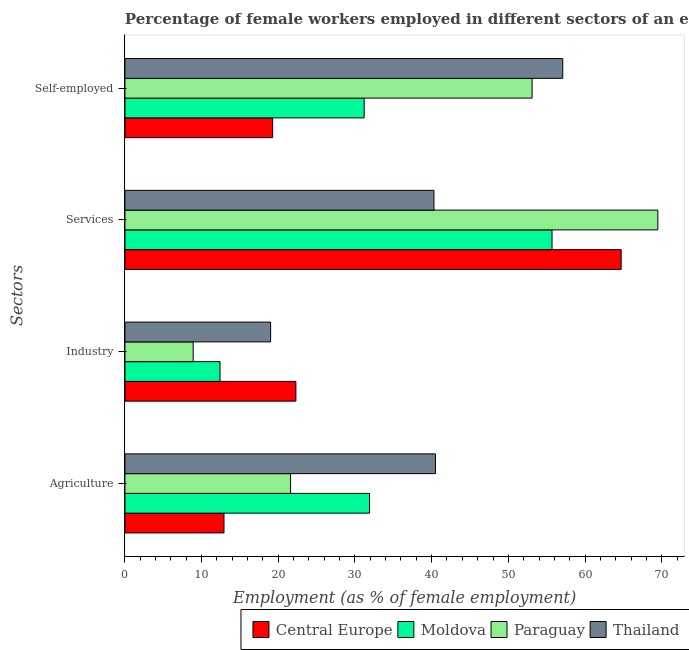Are the number of bars on each tick of the Y-axis equal?
Make the answer very short. Yes. How many bars are there on the 3rd tick from the top?
Your answer should be very brief. 4. How many bars are there on the 1st tick from the bottom?
Keep it short and to the point. 4. What is the label of the 2nd group of bars from the top?
Provide a succinct answer. Services. Across all countries, what is the maximum percentage of female workers in industry?
Ensure brevity in your answer.  22.29. Across all countries, what is the minimum percentage of female workers in services?
Give a very brief answer. 40.3. In which country was the percentage of female workers in agriculture maximum?
Keep it short and to the point. Thailand. In which country was the percentage of female workers in agriculture minimum?
Your response must be concise. Central Europe. What is the total percentage of female workers in services in the graph?
Your response must be concise. 230.21. What is the difference between the percentage of female workers in services in Thailand and that in Paraguay?
Give a very brief answer. -29.2. What is the difference between the percentage of female workers in agriculture in Moldova and the percentage of female workers in services in Thailand?
Your response must be concise. -8.4. What is the average percentage of female workers in industry per country?
Offer a very short reply. 15.65. What is the difference between the percentage of female workers in services and percentage of female workers in industry in Paraguay?
Keep it short and to the point. 60.6. What is the ratio of the percentage of female workers in services in Moldova to that in Paraguay?
Provide a succinct answer. 0.8. Is the percentage of self employed female workers in Moldova less than that in Paraguay?
Provide a short and direct response. Yes. Is the difference between the percentage of female workers in industry in Thailand and Moldova greater than the difference between the percentage of female workers in services in Thailand and Moldova?
Provide a short and direct response. Yes. What is the difference between the highest and the second highest percentage of female workers in agriculture?
Offer a very short reply. 8.6. What is the difference between the highest and the lowest percentage of female workers in industry?
Provide a short and direct response. 13.39. What does the 3rd bar from the top in Self-employed represents?
Your answer should be compact. Moldova. What does the 3rd bar from the bottom in Services represents?
Offer a terse response. Paraguay. Is it the case that in every country, the sum of the percentage of female workers in agriculture and percentage of female workers in industry is greater than the percentage of female workers in services?
Provide a short and direct response. No. Are all the bars in the graph horizontal?
Your answer should be very brief. Yes. How many countries are there in the graph?
Provide a short and direct response. 4. What is the difference between two consecutive major ticks on the X-axis?
Keep it short and to the point. 10. Does the graph contain any zero values?
Offer a very short reply. No. How are the legend labels stacked?
Your response must be concise. Horizontal. What is the title of the graph?
Offer a very short reply. Percentage of female workers employed in different sectors of an economy in 2006. What is the label or title of the X-axis?
Provide a short and direct response. Employment (as % of female employment). What is the label or title of the Y-axis?
Your response must be concise. Sectors. What is the Employment (as % of female employment) of Central Europe in Agriculture?
Give a very brief answer. 12.92. What is the Employment (as % of female employment) in Moldova in Agriculture?
Keep it short and to the point. 31.9. What is the Employment (as % of female employment) of Paraguay in Agriculture?
Give a very brief answer. 21.6. What is the Employment (as % of female employment) in Thailand in Agriculture?
Keep it short and to the point. 40.5. What is the Employment (as % of female employment) of Central Europe in Industry?
Your response must be concise. 22.29. What is the Employment (as % of female employment) of Moldova in Industry?
Make the answer very short. 12.4. What is the Employment (as % of female employment) in Paraguay in Industry?
Provide a short and direct response. 8.9. What is the Employment (as % of female employment) of Thailand in Industry?
Offer a terse response. 19. What is the Employment (as % of female employment) in Central Europe in Services?
Your answer should be very brief. 64.71. What is the Employment (as % of female employment) in Moldova in Services?
Provide a succinct answer. 55.7. What is the Employment (as % of female employment) of Paraguay in Services?
Offer a very short reply. 69.5. What is the Employment (as % of female employment) of Thailand in Services?
Keep it short and to the point. 40.3. What is the Employment (as % of female employment) of Central Europe in Self-employed?
Your answer should be compact. 19.26. What is the Employment (as % of female employment) in Moldova in Self-employed?
Provide a succinct answer. 31.2. What is the Employment (as % of female employment) of Paraguay in Self-employed?
Offer a terse response. 53.1. What is the Employment (as % of female employment) of Thailand in Self-employed?
Your answer should be very brief. 57.1. Across all Sectors, what is the maximum Employment (as % of female employment) of Central Europe?
Make the answer very short. 64.71. Across all Sectors, what is the maximum Employment (as % of female employment) of Moldova?
Your answer should be very brief. 55.7. Across all Sectors, what is the maximum Employment (as % of female employment) of Paraguay?
Offer a very short reply. 69.5. Across all Sectors, what is the maximum Employment (as % of female employment) in Thailand?
Make the answer very short. 57.1. Across all Sectors, what is the minimum Employment (as % of female employment) of Central Europe?
Make the answer very short. 12.92. Across all Sectors, what is the minimum Employment (as % of female employment) in Moldova?
Ensure brevity in your answer.  12.4. Across all Sectors, what is the minimum Employment (as % of female employment) of Paraguay?
Keep it short and to the point. 8.9. Across all Sectors, what is the minimum Employment (as % of female employment) in Thailand?
Your answer should be compact. 19. What is the total Employment (as % of female employment) in Central Europe in the graph?
Keep it short and to the point. 119.19. What is the total Employment (as % of female employment) of Moldova in the graph?
Ensure brevity in your answer.  131.2. What is the total Employment (as % of female employment) of Paraguay in the graph?
Offer a very short reply. 153.1. What is the total Employment (as % of female employment) of Thailand in the graph?
Give a very brief answer. 156.9. What is the difference between the Employment (as % of female employment) in Central Europe in Agriculture and that in Industry?
Provide a short and direct response. -9.37. What is the difference between the Employment (as % of female employment) in Moldova in Agriculture and that in Industry?
Provide a succinct answer. 19.5. What is the difference between the Employment (as % of female employment) in Paraguay in Agriculture and that in Industry?
Your answer should be compact. 12.7. What is the difference between the Employment (as % of female employment) of Central Europe in Agriculture and that in Services?
Offer a terse response. -51.8. What is the difference between the Employment (as % of female employment) of Moldova in Agriculture and that in Services?
Give a very brief answer. -23.8. What is the difference between the Employment (as % of female employment) of Paraguay in Agriculture and that in Services?
Make the answer very short. -47.9. What is the difference between the Employment (as % of female employment) of Central Europe in Agriculture and that in Self-employed?
Ensure brevity in your answer.  -6.34. What is the difference between the Employment (as % of female employment) in Paraguay in Agriculture and that in Self-employed?
Provide a short and direct response. -31.5. What is the difference between the Employment (as % of female employment) in Thailand in Agriculture and that in Self-employed?
Your answer should be very brief. -16.6. What is the difference between the Employment (as % of female employment) of Central Europe in Industry and that in Services?
Make the answer very short. -42.42. What is the difference between the Employment (as % of female employment) in Moldova in Industry and that in Services?
Make the answer very short. -43.3. What is the difference between the Employment (as % of female employment) of Paraguay in Industry and that in Services?
Provide a succinct answer. -60.6. What is the difference between the Employment (as % of female employment) of Thailand in Industry and that in Services?
Your answer should be very brief. -21.3. What is the difference between the Employment (as % of female employment) of Central Europe in Industry and that in Self-employed?
Keep it short and to the point. 3.03. What is the difference between the Employment (as % of female employment) in Moldova in Industry and that in Self-employed?
Your answer should be compact. -18.8. What is the difference between the Employment (as % of female employment) in Paraguay in Industry and that in Self-employed?
Give a very brief answer. -44.2. What is the difference between the Employment (as % of female employment) in Thailand in Industry and that in Self-employed?
Keep it short and to the point. -38.1. What is the difference between the Employment (as % of female employment) in Central Europe in Services and that in Self-employed?
Keep it short and to the point. 45.45. What is the difference between the Employment (as % of female employment) in Paraguay in Services and that in Self-employed?
Make the answer very short. 16.4. What is the difference between the Employment (as % of female employment) in Thailand in Services and that in Self-employed?
Your response must be concise. -16.8. What is the difference between the Employment (as % of female employment) in Central Europe in Agriculture and the Employment (as % of female employment) in Moldova in Industry?
Offer a very short reply. 0.52. What is the difference between the Employment (as % of female employment) of Central Europe in Agriculture and the Employment (as % of female employment) of Paraguay in Industry?
Your answer should be very brief. 4.02. What is the difference between the Employment (as % of female employment) of Central Europe in Agriculture and the Employment (as % of female employment) of Thailand in Industry?
Offer a very short reply. -6.08. What is the difference between the Employment (as % of female employment) of Moldova in Agriculture and the Employment (as % of female employment) of Paraguay in Industry?
Make the answer very short. 23. What is the difference between the Employment (as % of female employment) of Moldova in Agriculture and the Employment (as % of female employment) of Thailand in Industry?
Your answer should be very brief. 12.9. What is the difference between the Employment (as % of female employment) of Central Europe in Agriculture and the Employment (as % of female employment) of Moldova in Services?
Provide a succinct answer. -42.78. What is the difference between the Employment (as % of female employment) in Central Europe in Agriculture and the Employment (as % of female employment) in Paraguay in Services?
Your answer should be compact. -56.58. What is the difference between the Employment (as % of female employment) of Central Europe in Agriculture and the Employment (as % of female employment) of Thailand in Services?
Provide a short and direct response. -27.38. What is the difference between the Employment (as % of female employment) in Moldova in Agriculture and the Employment (as % of female employment) in Paraguay in Services?
Offer a terse response. -37.6. What is the difference between the Employment (as % of female employment) in Moldova in Agriculture and the Employment (as % of female employment) in Thailand in Services?
Your answer should be very brief. -8.4. What is the difference between the Employment (as % of female employment) in Paraguay in Agriculture and the Employment (as % of female employment) in Thailand in Services?
Make the answer very short. -18.7. What is the difference between the Employment (as % of female employment) in Central Europe in Agriculture and the Employment (as % of female employment) in Moldova in Self-employed?
Offer a very short reply. -18.28. What is the difference between the Employment (as % of female employment) in Central Europe in Agriculture and the Employment (as % of female employment) in Paraguay in Self-employed?
Ensure brevity in your answer.  -40.18. What is the difference between the Employment (as % of female employment) of Central Europe in Agriculture and the Employment (as % of female employment) of Thailand in Self-employed?
Offer a very short reply. -44.18. What is the difference between the Employment (as % of female employment) in Moldova in Agriculture and the Employment (as % of female employment) in Paraguay in Self-employed?
Make the answer very short. -21.2. What is the difference between the Employment (as % of female employment) in Moldova in Agriculture and the Employment (as % of female employment) in Thailand in Self-employed?
Your response must be concise. -25.2. What is the difference between the Employment (as % of female employment) in Paraguay in Agriculture and the Employment (as % of female employment) in Thailand in Self-employed?
Provide a succinct answer. -35.5. What is the difference between the Employment (as % of female employment) of Central Europe in Industry and the Employment (as % of female employment) of Moldova in Services?
Your response must be concise. -33.41. What is the difference between the Employment (as % of female employment) in Central Europe in Industry and the Employment (as % of female employment) in Paraguay in Services?
Your response must be concise. -47.21. What is the difference between the Employment (as % of female employment) in Central Europe in Industry and the Employment (as % of female employment) in Thailand in Services?
Make the answer very short. -18.01. What is the difference between the Employment (as % of female employment) in Moldova in Industry and the Employment (as % of female employment) in Paraguay in Services?
Keep it short and to the point. -57.1. What is the difference between the Employment (as % of female employment) of Moldova in Industry and the Employment (as % of female employment) of Thailand in Services?
Keep it short and to the point. -27.9. What is the difference between the Employment (as % of female employment) in Paraguay in Industry and the Employment (as % of female employment) in Thailand in Services?
Your response must be concise. -31.4. What is the difference between the Employment (as % of female employment) of Central Europe in Industry and the Employment (as % of female employment) of Moldova in Self-employed?
Provide a succinct answer. -8.91. What is the difference between the Employment (as % of female employment) in Central Europe in Industry and the Employment (as % of female employment) in Paraguay in Self-employed?
Provide a short and direct response. -30.81. What is the difference between the Employment (as % of female employment) of Central Europe in Industry and the Employment (as % of female employment) of Thailand in Self-employed?
Make the answer very short. -34.81. What is the difference between the Employment (as % of female employment) of Moldova in Industry and the Employment (as % of female employment) of Paraguay in Self-employed?
Your response must be concise. -40.7. What is the difference between the Employment (as % of female employment) in Moldova in Industry and the Employment (as % of female employment) in Thailand in Self-employed?
Give a very brief answer. -44.7. What is the difference between the Employment (as % of female employment) in Paraguay in Industry and the Employment (as % of female employment) in Thailand in Self-employed?
Keep it short and to the point. -48.2. What is the difference between the Employment (as % of female employment) in Central Europe in Services and the Employment (as % of female employment) in Moldova in Self-employed?
Your answer should be very brief. 33.51. What is the difference between the Employment (as % of female employment) in Central Europe in Services and the Employment (as % of female employment) in Paraguay in Self-employed?
Make the answer very short. 11.61. What is the difference between the Employment (as % of female employment) in Central Europe in Services and the Employment (as % of female employment) in Thailand in Self-employed?
Provide a succinct answer. 7.61. What is the difference between the Employment (as % of female employment) of Paraguay in Services and the Employment (as % of female employment) of Thailand in Self-employed?
Offer a terse response. 12.4. What is the average Employment (as % of female employment) of Central Europe per Sectors?
Keep it short and to the point. 29.8. What is the average Employment (as % of female employment) of Moldova per Sectors?
Ensure brevity in your answer.  32.8. What is the average Employment (as % of female employment) of Paraguay per Sectors?
Ensure brevity in your answer.  38.27. What is the average Employment (as % of female employment) in Thailand per Sectors?
Keep it short and to the point. 39.23. What is the difference between the Employment (as % of female employment) in Central Europe and Employment (as % of female employment) in Moldova in Agriculture?
Offer a very short reply. -18.98. What is the difference between the Employment (as % of female employment) of Central Europe and Employment (as % of female employment) of Paraguay in Agriculture?
Give a very brief answer. -8.68. What is the difference between the Employment (as % of female employment) in Central Europe and Employment (as % of female employment) in Thailand in Agriculture?
Provide a succinct answer. -27.58. What is the difference between the Employment (as % of female employment) of Paraguay and Employment (as % of female employment) of Thailand in Agriculture?
Provide a succinct answer. -18.9. What is the difference between the Employment (as % of female employment) of Central Europe and Employment (as % of female employment) of Moldova in Industry?
Your answer should be compact. 9.89. What is the difference between the Employment (as % of female employment) in Central Europe and Employment (as % of female employment) in Paraguay in Industry?
Provide a short and direct response. 13.39. What is the difference between the Employment (as % of female employment) of Central Europe and Employment (as % of female employment) of Thailand in Industry?
Your answer should be compact. 3.29. What is the difference between the Employment (as % of female employment) of Moldova and Employment (as % of female employment) of Thailand in Industry?
Make the answer very short. -6.6. What is the difference between the Employment (as % of female employment) of Central Europe and Employment (as % of female employment) of Moldova in Services?
Offer a very short reply. 9.01. What is the difference between the Employment (as % of female employment) of Central Europe and Employment (as % of female employment) of Paraguay in Services?
Provide a succinct answer. -4.79. What is the difference between the Employment (as % of female employment) in Central Europe and Employment (as % of female employment) in Thailand in Services?
Ensure brevity in your answer.  24.41. What is the difference between the Employment (as % of female employment) in Moldova and Employment (as % of female employment) in Paraguay in Services?
Keep it short and to the point. -13.8. What is the difference between the Employment (as % of female employment) in Moldova and Employment (as % of female employment) in Thailand in Services?
Keep it short and to the point. 15.4. What is the difference between the Employment (as % of female employment) of Paraguay and Employment (as % of female employment) of Thailand in Services?
Your answer should be compact. 29.2. What is the difference between the Employment (as % of female employment) of Central Europe and Employment (as % of female employment) of Moldova in Self-employed?
Your answer should be compact. -11.94. What is the difference between the Employment (as % of female employment) of Central Europe and Employment (as % of female employment) of Paraguay in Self-employed?
Make the answer very short. -33.84. What is the difference between the Employment (as % of female employment) of Central Europe and Employment (as % of female employment) of Thailand in Self-employed?
Make the answer very short. -37.84. What is the difference between the Employment (as % of female employment) in Moldova and Employment (as % of female employment) in Paraguay in Self-employed?
Your answer should be compact. -21.9. What is the difference between the Employment (as % of female employment) of Moldova and Employment (as % of female employment) of Thailand in Self-employed?
Offer a terse response. -25.9. What is the ratio of the Employment (as % of female employment) in Central Europe in Agriculture to that in Industry?
Provide a short and direct response. 0.58. What is the ratio of the Employment (as % of female employment) in Moldova in Agriculture to that in Industry?
Your answer should be compact. 2.57. What is the ratio of the Employment (as % of female employment) in Paraguay in Agriculture to that in Industry?
Provide a succinct answer. 2.43. What is the ratio of the Employment (as % of female employment) of Thailand in Agriculture to that in Industry?
Make the answer very short. 2.13. What is the ratio of the Employment (as % of female employment) in Central Europe in Agriculture to that in Services?
Provide a succinct answer. 0.2. What is the ratio of the Employment (as % of female employment) in Moldova in Agriculture to that in Services?
Offer a terse response. 0.57. What is the ratio of the Employment (as % of female employment) in Paraguay in Agriculture to that in Services?
Offer a very short reply. 0.31. What is the ratio of the Employment (as % of female employment) of Thailand in Agriculture to that in Services?
Provide a short and direct response. 1. What is the ratio of the Employment (as % of female employment) of Central Europe in Agriculture to that in Self-employed?
Give a very brief answer. 0.67. What is the ratio of the Employment (as % of female employment) of Moldova in Agriculture to that in Self-employed?
Provide a short and direct response. 1.02. What is the ratio of the Employment (as % of female employment) in Paraguay in Agriculture to that in Self-employed?
Give a very brief answer. 0.41. What is the ratio of the Employment (as % of female employment) of Thailand in Agriculture to that in Self-employed?
Keep it short and to the point. 0.71. What is the ratio of the Employment (as % of female employment) in Central Europe in Industry to that in Services?
Offer a terse response. 0.34. What is the ratio of the Employment (as % of female employment) in Moldova in Industry to that in Services?
Offer a very short reply. 0.22. What is the ratio of the Employment (as % of female employment) of Paraguay in Industry to that in Services?
Offer a very short reply. 0.13. What is the ratio of the Employment (as % of female employment) in Thailand in Industry to that in Services?
Your answer should be very brief. 0.47. What is the ratio of the Employment (as % of female employment) of Central Europe in Industry to that in Self-employed?
Make the answer very short. 1.16. What is the ratio of the Employment (as % of female employment) in Moldova in Industry to that in Self-employed?
Provide a short and direct response. 0.4. What is the ratio of the Employment (as % of female employment) in Paraguay in Industry to that in Self-employed?
Your answer should be compact. 0.17. What is the ratio of the Employment (as % of female employment) in Thailand in Industry to that in Self-employed?
Make the answer very short. 0.33. What is the ratio of the Employment (as % of female employment) in Central Europe in Services to that in Self-employed?
Give a very brief answer. 3.36. What is the ratio of the Employment (as % of female employment) in Moldova in Services to that in Self-employed?
Your answer should be compact. 1.79. What is the ratio of the Employment (as % of female employment) in Paraguay in Services to that in Self-employed?
Give a very brief answer. 1.31. What is the ratio of the Employment (as % of female employment) of Thailand in Services to that in Self-employed?
Offer a terse response. 0.71. What is the difference between the highest and the second highest Employment (as % of female employment) in Central Europe?
Give a very brief answer. 42.42. What is the difference between the highest and the second highest Employment (as % of female employment) of Moldova?
Offer a terse response. 23.8. What is the difference between the highest and the second highest Employment (as % of female employment) of Thailand?
Provide a succinct answer. 16.6. What is the difference between the highest and the lowest Employment (as % of female employment) of Central Europe?
Offer a terse response. 51.8. What is the difference between the highest and the lowest Employment (as % of female employment) in Moldova?
Give a very brief answer. 43.3. What is the difference between the highest and the lowest Employment (as % of female employment) in Paraguay?
Give a very brief answer. 60.6. What is the difference between the highest and the lowest Employment (as % of female employment) of Thailand?
Ensure brevity in your answer.  38.1. 